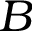Convert formula to latex. <formula><loc_0><loc_0><loc_500><loc_500>B</formula> 